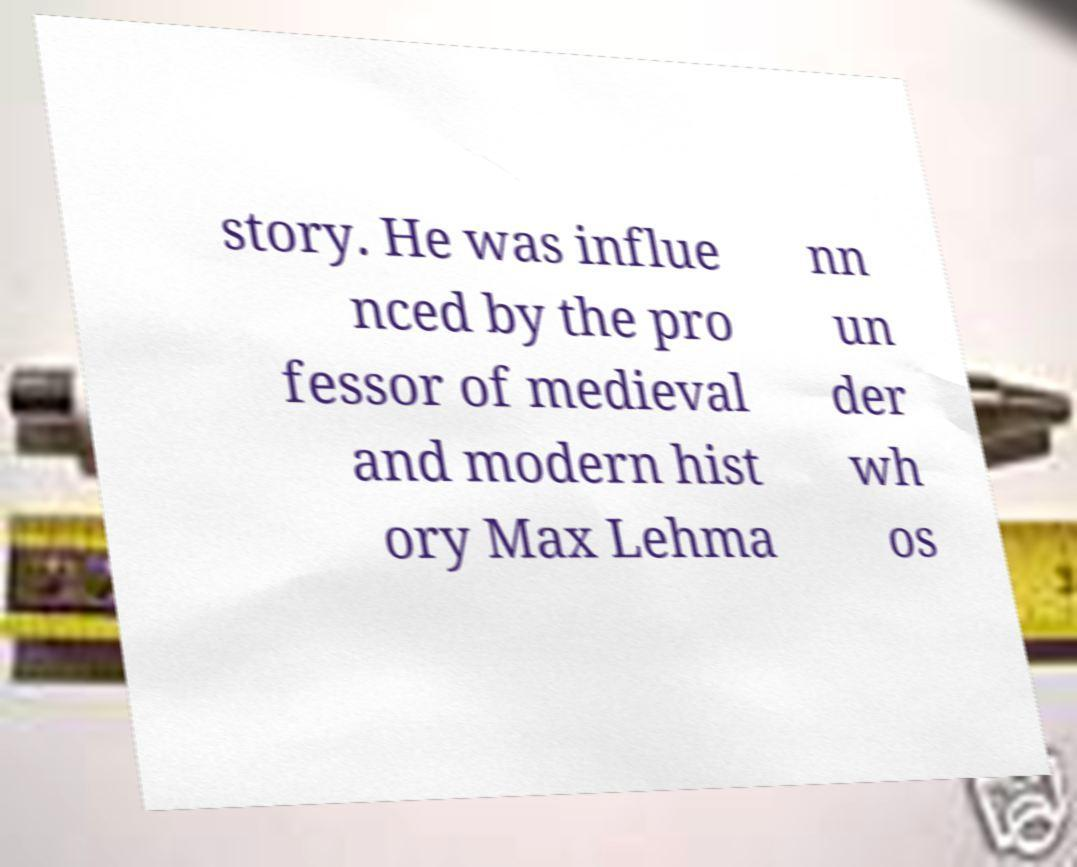Can you accurately transcribe the text from the provided image for me? story. He was influe nced by the pro fessor of medieval and modern hist ory Max Lehma nn un der wh os 